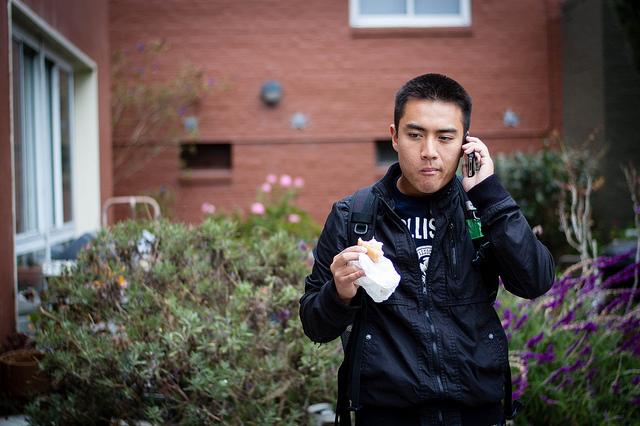What is in the picture?
Concise answer only. Man. Is he talking on the phone?
Concise answer only. Yes. Is the man eating?
Short answer required. Yes. 